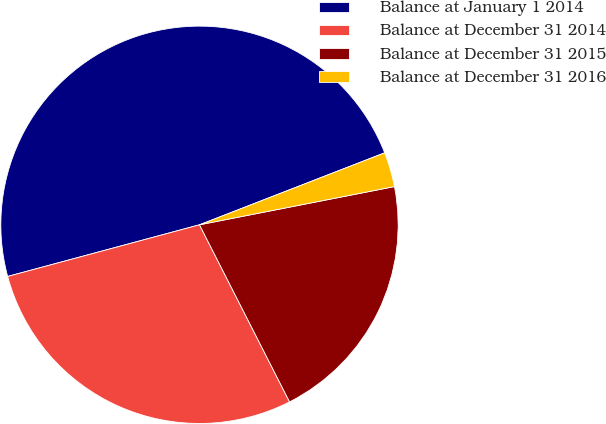<chart> <loc_0><loc_0><loc_500><loc_500><pie_chart><fcel>Balance at January 1 2014<fcel>Balance at December 31 2014<fcel>Balance at December 31 2015<fcel>Balance at December 31 2016<nl><fcel>48.28%<fcel>28.3%<fcel>20.59%<fcel>2.82%<nl></chart> 